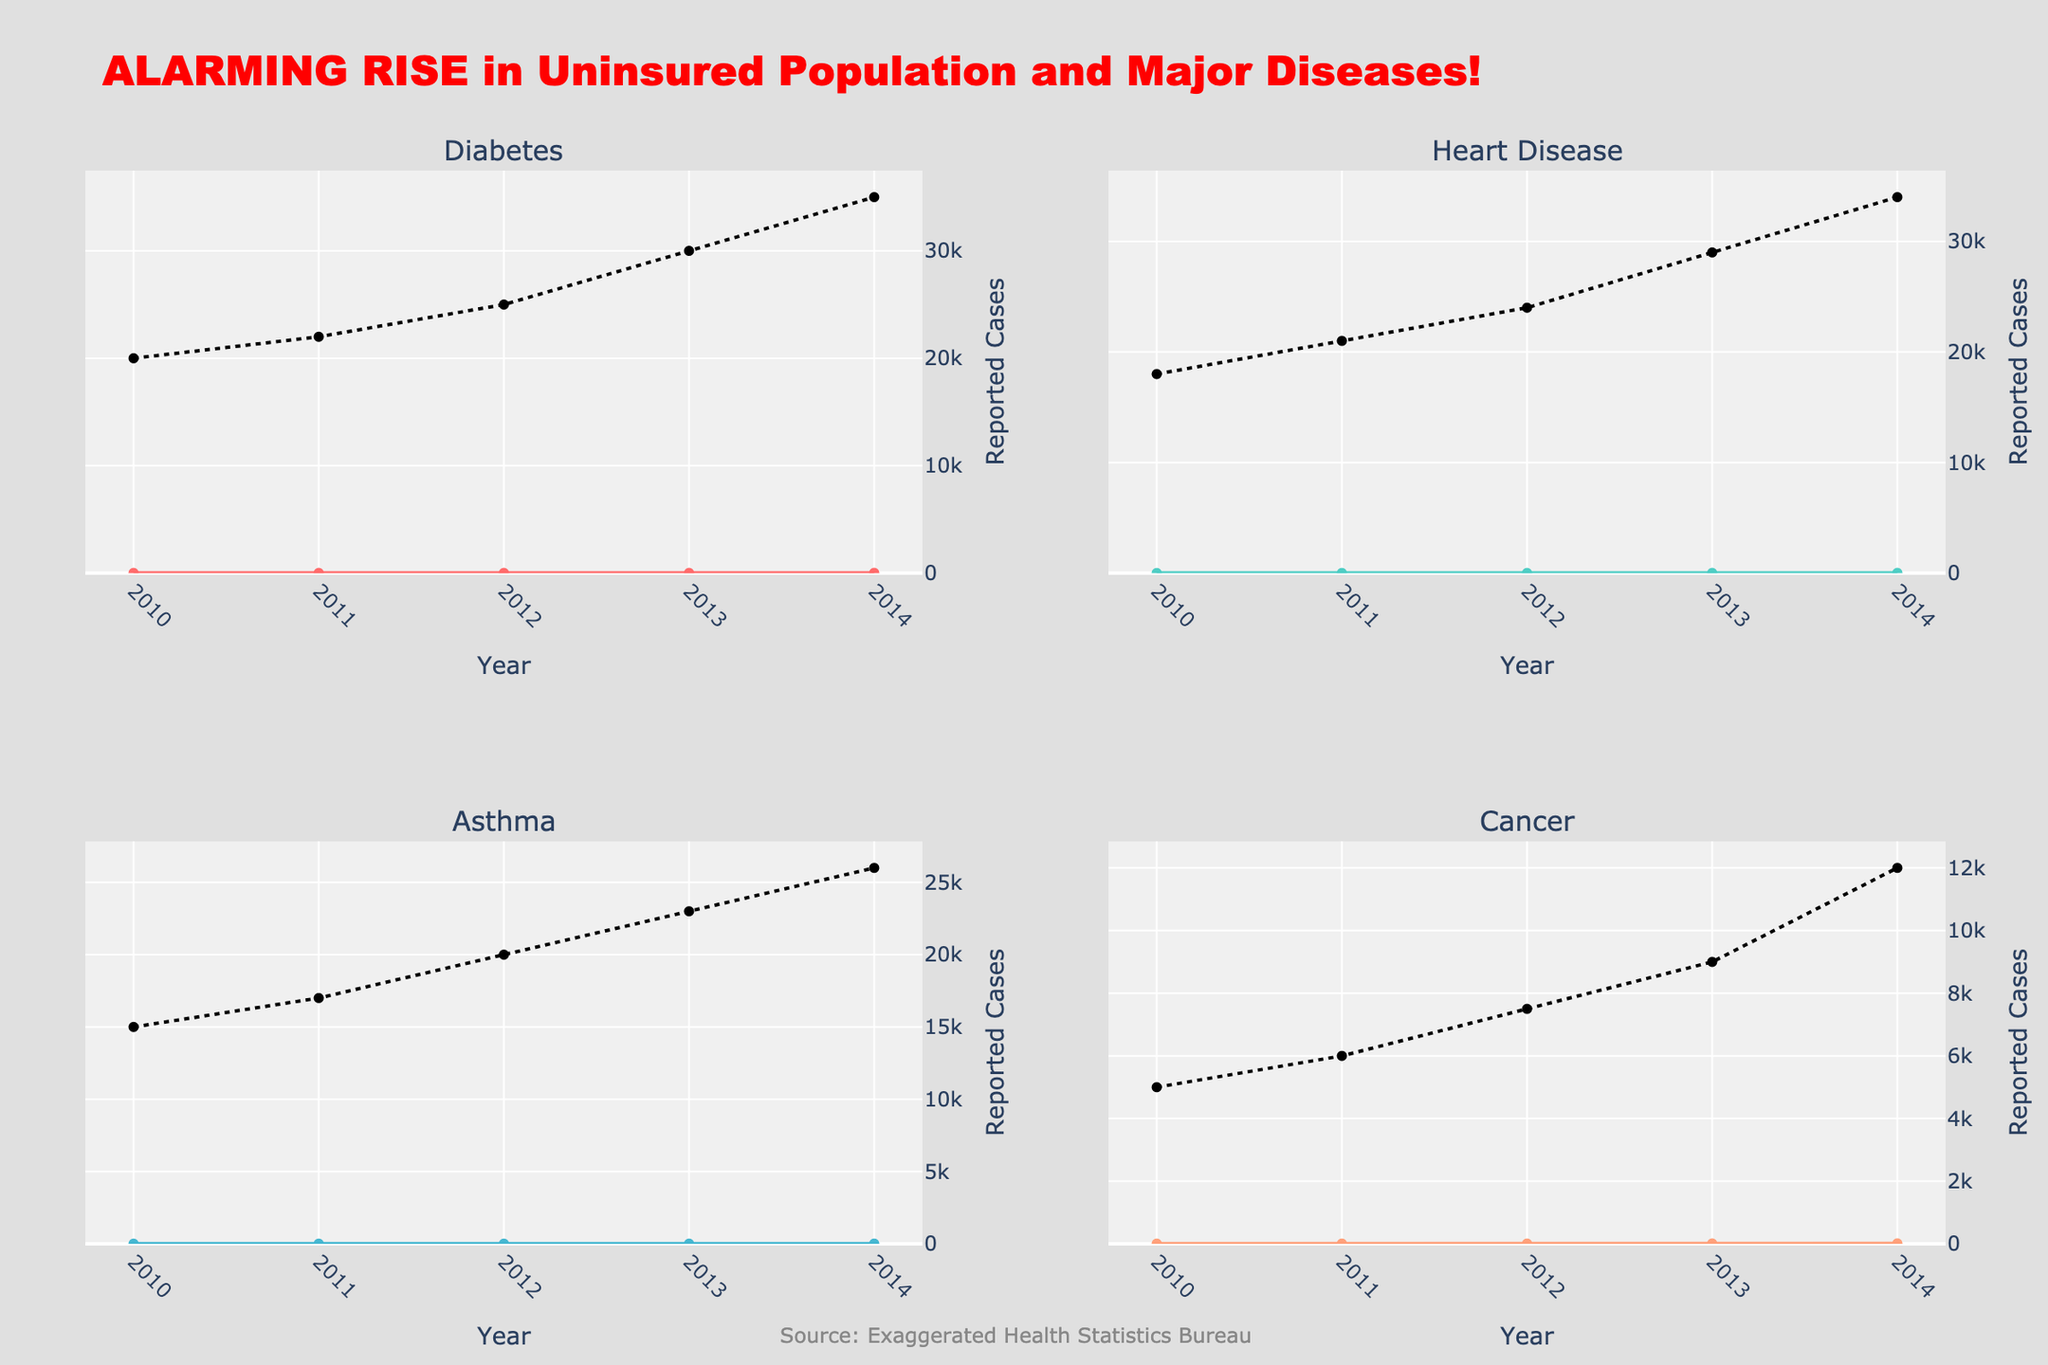Which disease had the highest uninsured percentage in 2014? Look at the uninsured percentages for all diseases in 2014. Diabetes has the highest uninsured percentage at 21%.
Answer: Diabetes What is the general trend of uninsured percentages for Heart Disease from 2010 to 2014? Examine the area chart for Heart Disease. It shows an increasing trend from 10% in 2010 to 19% in 2014.
Answer: Increasing How many total reported cases of Asthma were there in 2012 and 2013 combined? Add the reported cases of Asthma for 2012 (20,000) and 2013 (23,000). The total is 43,000.
Answer: 43,000 Which disease shows the most significant increase in reported cases between 2010 and 2014? Compare the reported cases for each disease in 2010 and 2014. Diabetes increased by 15,000 cases, Heart Disease by 16,000 cases, Asthma by 11,000 cases, and Cancer by 7,000 cases. Heart Disease had the largest increase.
Answer: Heart Disease Between Cancer and Asthma, which had a higher reported number of cases in 2014? Look at the reported cases for Cancer (12,000) and Asthma (26,000) in 2014. Asthma has a higher number of reported cases.
Answer: Asthma What percentage of uninsured individuals had Asthma in 2013? Refer to the area chart for Asthma in 2013. The uninsured percentage is 15%.
Answer: 15% How did the uninsured percentage for Diabetes change between 2012 and 2013? Look at the uninsured percentages for Diabetes. It increased from 17% in 2012 to 19% in 2013.
Answer: Increased by 2% Which diseases have a higher uninsured percentage than Cancer in 2014? Compare the uninsured percentages in 2014 for Cancer (15%) with other diseases. Diabetes (21%), Heart Disease (19%), and Asthma (17%) are higher.
Answer: Diabetes, Heart Disease, Asthma What is the average uninsured percentage for Heart Disease over the years 2010-2014? Add the uninsured percentages for Heart Disease from 2010 to 2014 (10+11+13+16+19) and divide by 5. The average is 13.8%.
Answer: 13.8% Which subplot shows the highest peak of uninsured percentage? Look at the highest points of the area charts in each subplot. Diabetes has the highest peak at 21%.
Answer: Diabetes 